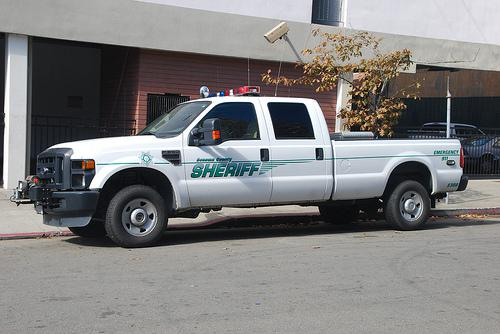Question: what does it say on the truck door?
Choices:
A. Police.
B. Dog Catcher.
C. Sheriff.
D. Telephone Company.
Answer with the letter. Answer: C Question: whose truck is this?
Choices:
A. Police.
B. Dog Catcher.
C. Sheriff.
D. Public Works.
Answer with the letter. Answer: C Question: who rides in this truck?
Choices:
A. Police.
B. Sheriffs.
C. Firemen.
D. Garbage Man.
Answer with the letter. Answer: B Question: how do the sheriffs get in the truck?
Choices:
A. The door.
B. The window.
C. Hopping.
D. Quickly.
Answer with the letter. Answer: A Question: what do they do with the truck?
Choices:
A. Look at it.
B. Load it.
C. Wash it.
D. Drive it.
Answer with the letter. Answer: D 